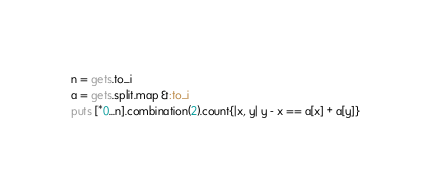<code> <loc_0><loc_0><loc_500><loc_500><_Ruby_>n = gets.to_i
a = gets.split.map &:to_i
puts [*0...n].combination(2).count{|x, y| y - x == a[x] + a[y]}</code> 